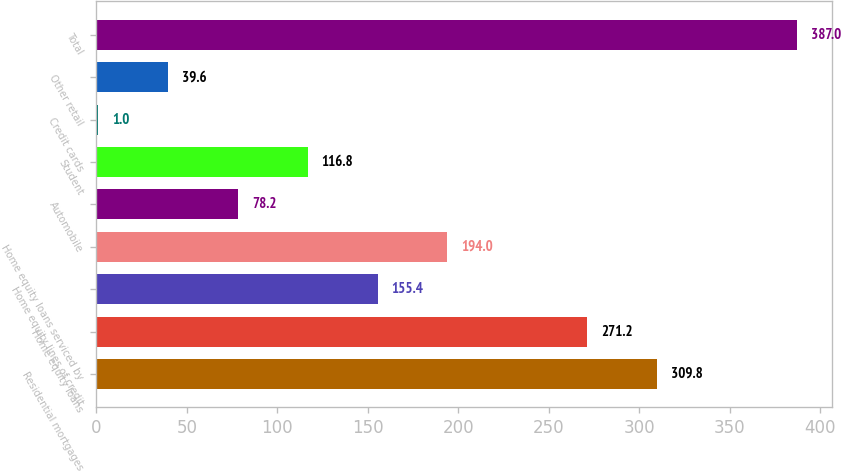<chart> <loc_0><loc_0><loc_500><loc_500><bar_chart><fcel>Residential mortgages<fcel>Home equity loans<fcel>Home equity lines of credit<fcel>Home equity loans serviced by<fcel>Automobile<fcel>Student<fcel>Credit cards<fcel>Other retail<fcel>Total<nl><fcel>309.8<fcel>271.2<fcel>155.4<fcel>194<fcel>78.2<fcel>116.8<fcel>1<fcel>39.6<fcel>387<nl></chart> 